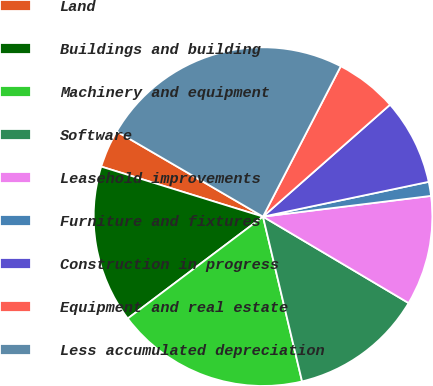<chart> <loc_0><loc_0><loc_500><loc_500><pie_chart><fcel>Land<fcel>Buildings and building<fcel>Machinery and equipment<fcel>Software<fcel>Leasehold improvements<fcel>Furniture and fixtures<fcel>Construction in progress<fcel>Equipment and real estate<fcel>Less accumulated depreciation<nl><fcel>3.62%<fcel>15.05%<fcel>18.43%<fcel>12.77%<fcel>10.48%<fcel>1.34%<fcel>8.2%<fcel>5.91%<fcel>24.2%<nl></chart> 